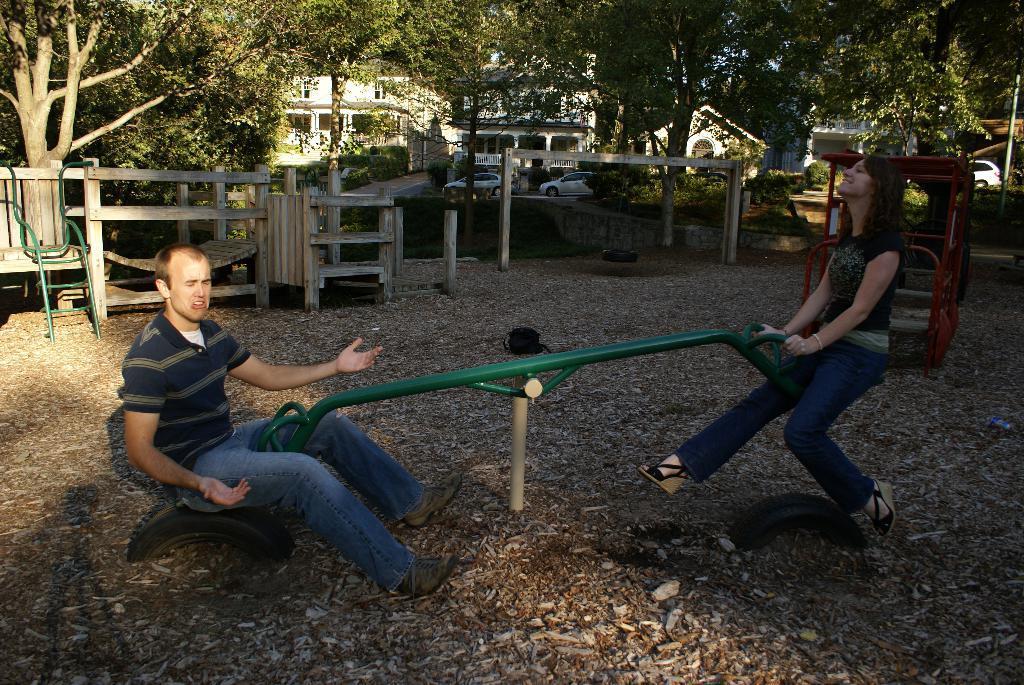How would you summarize this image in a sentence or two? In front of the picture, we see the man and the women are playing the seesaw. At the bottom, we see the twigs, sand and the tyres. On the left side, we see the wooden bench and tables. On the right side, we see the red color playing object. There are trees and buildings in the background. We see the cars are moving on the road. This picture might be clicked in the park. 